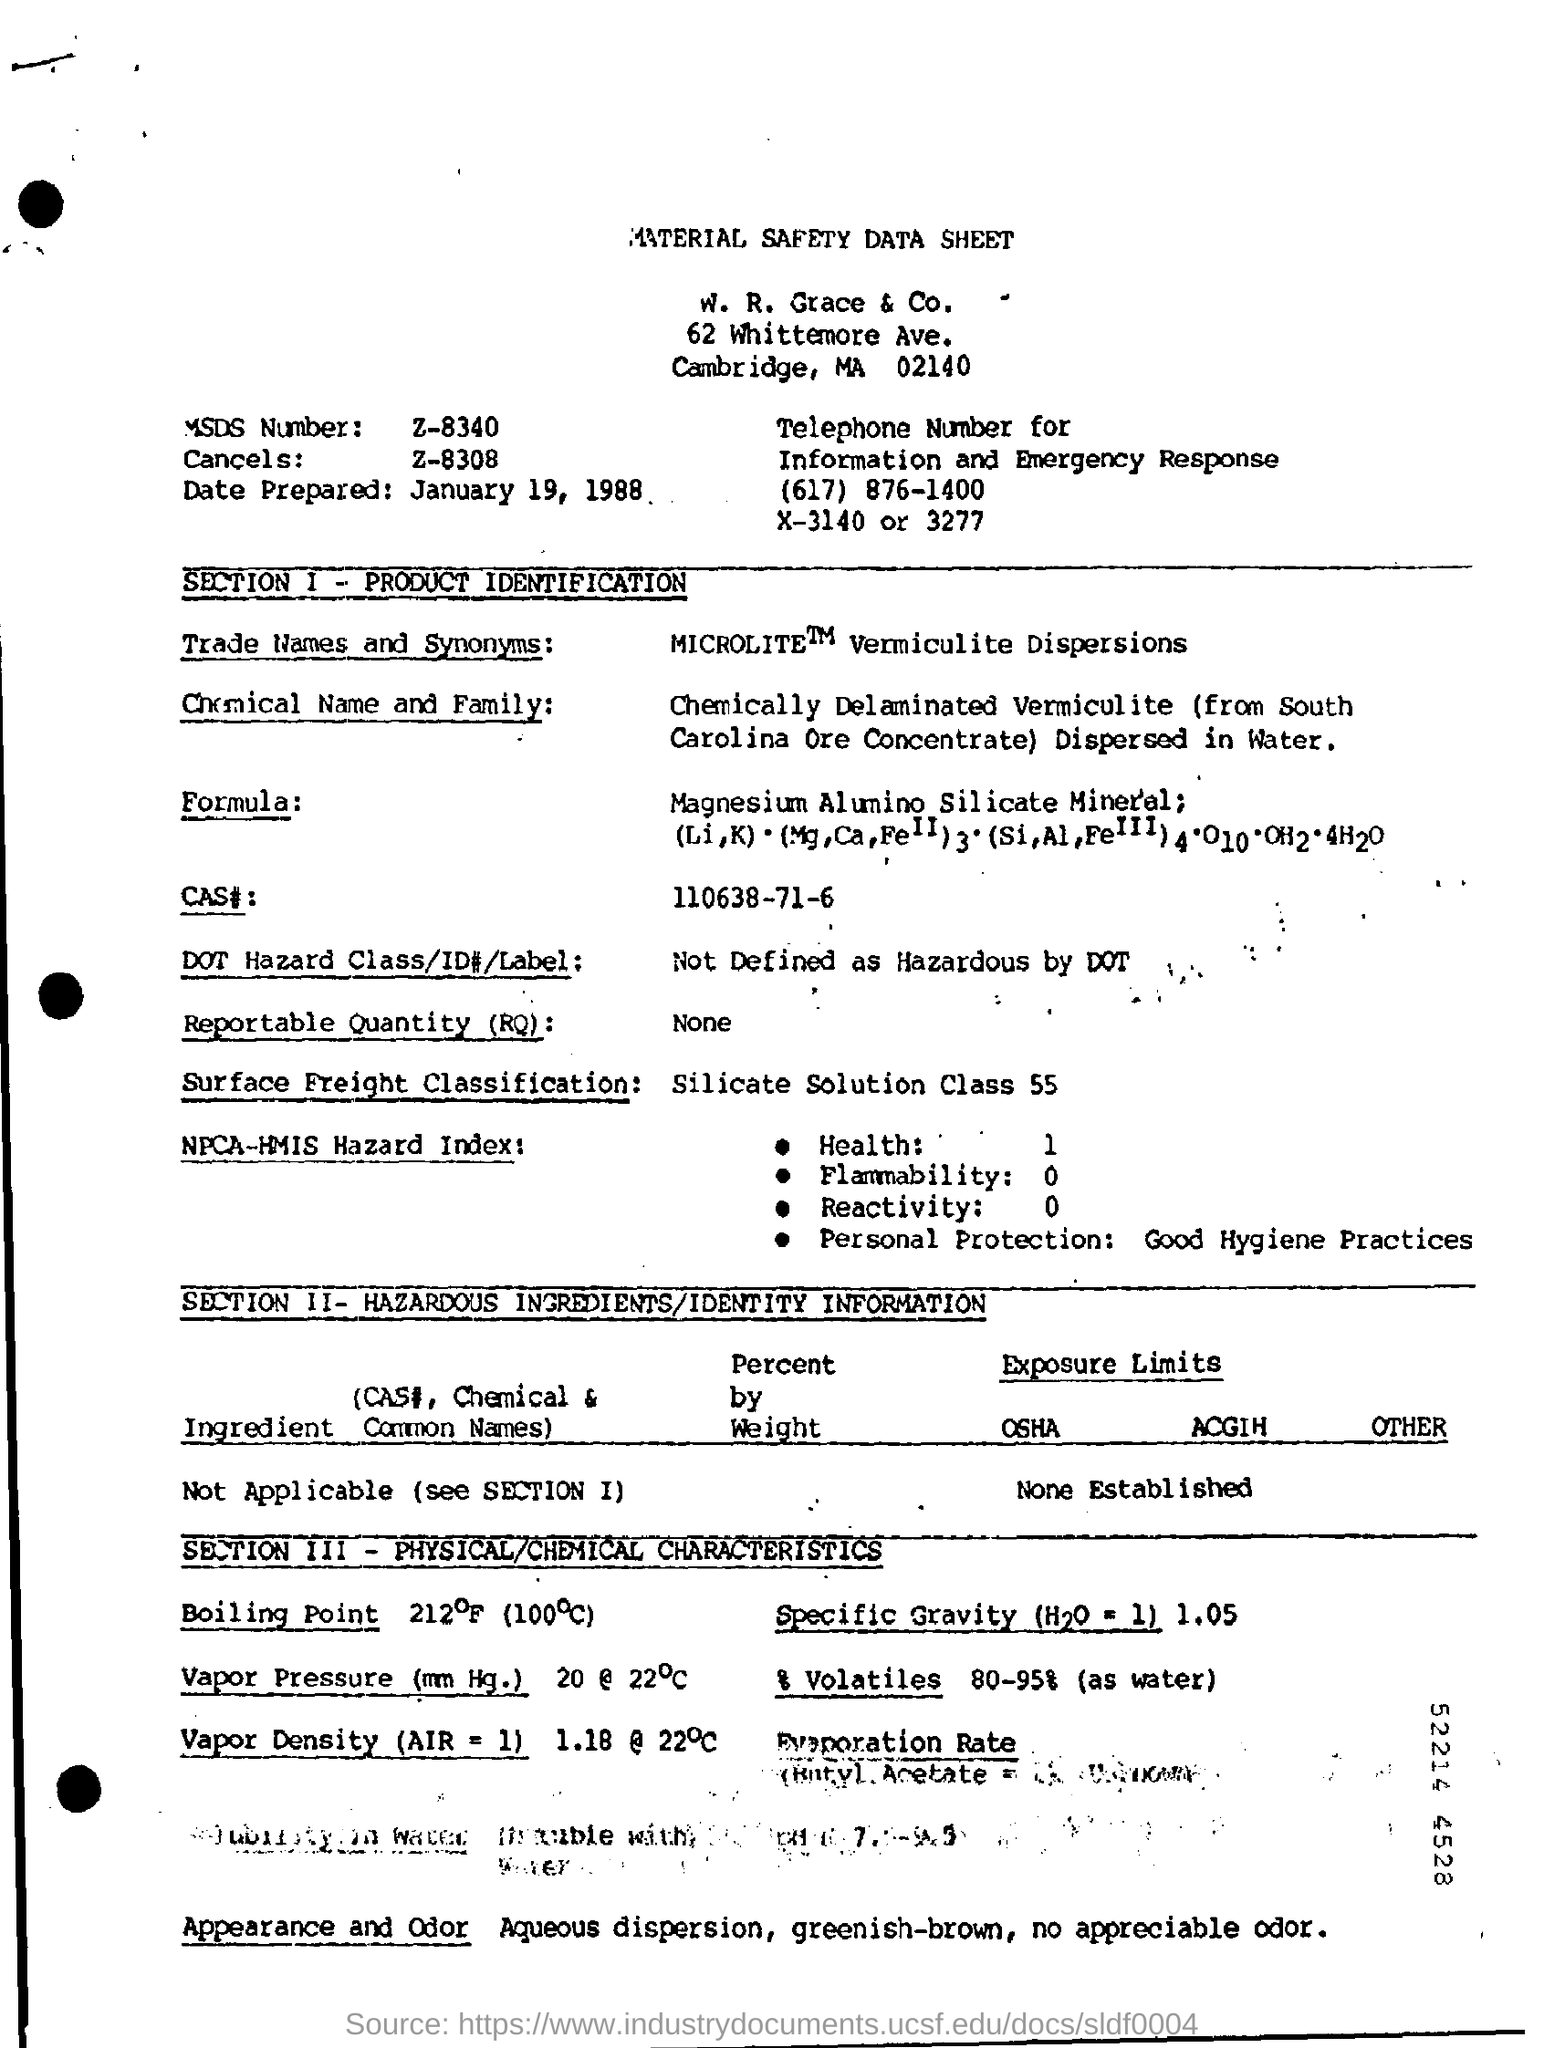What is the heading at top of the page ?
Offer a terse response. Material safety data sheet. 